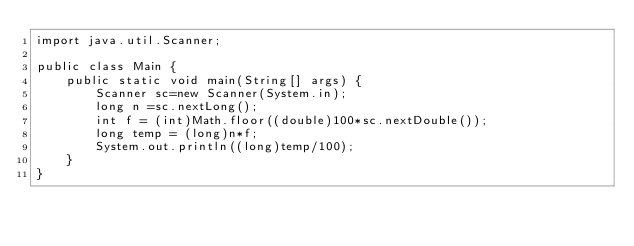Convert code to text. <code><loc_0><loc_0><loc_500><loc_500><_Java_>import java.util.Scanner;

public class Main {
	public static void main(String[] args) {
		Scanner sc=new Scanner(System.in);
		long n =sc.nextLong();
		int f = (int)Math.floor((double)100*sc.nextDouble());
		long temp = (long)n*f;
		System.out.println((long)temp/100);
	}
}</code> 